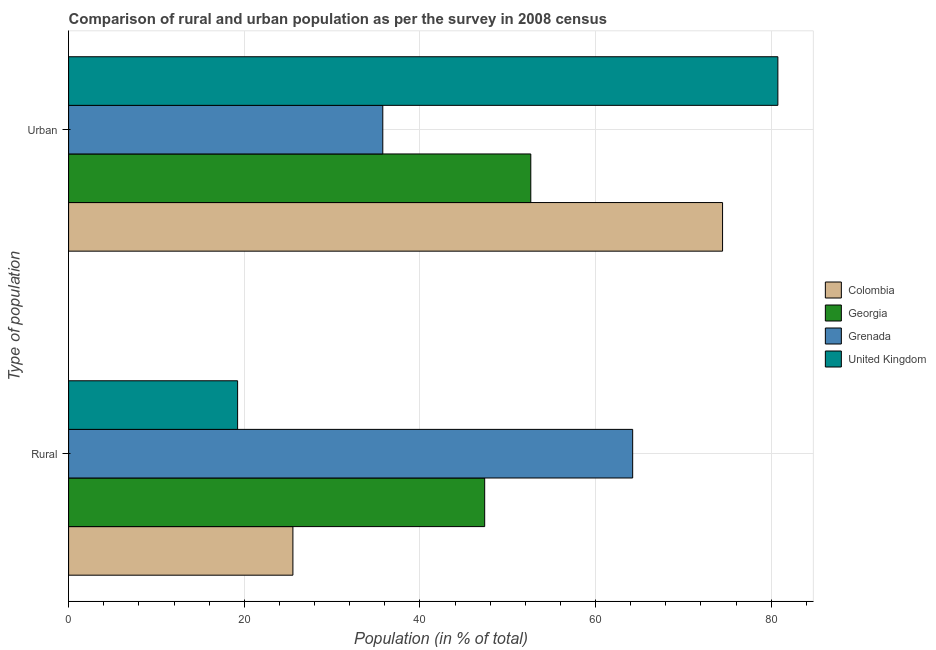How many groups of bars are there?
Offer a terse response. 2. Are the number of bars per tick equal to the number of legend labels?
Provide a succinct answer. Yes. Are the number of bars on each tick of the Y-axis equal?
Provide a succinct answer. Yes. How many bars are there on the 1st tick from the bottom?
Your response must be concise. 4. What is the label of the 1st group of bars from the top?
Make the answer very short. Urban. What is the urban population in Georgia?
Keep it short and to the point. 52.62. Across all countries, what is the maximum rural population?
Make the answer very short. 64.22. Across all countries, what is the minimum rural population?
Offer a terse response. 19.24. In which country was the urban population minimum?
Make the answer very short. Grenada. What is the total rural population in the graph?
Make the answer very short. 156.38. What is the difference between the urban population in Grenada and that in Colombia?
Give a very brief answer. -38.68. What is the difference between the urban population in Grenada and the rural population in United Kingdom?
Offer a terse response. 16.53. What is the average rural population per country?
Provide a succinct answer. 39.1. What is the difference between the rural population and urban population in United Kingdom?
Your answer should be very brief. -61.51. What is the ratio of the urban population in Colombia to that in United Kingdom?
Your answer should be very brief. 0.92. In how many countries, is the urban population greater than the average urban population taken over all countries?
Your answer should be compact. 2. What does the 4th bar from the bottom in Urban represents?
Your answer should be very brief. United Kingdom. Does the graph contain any zero values?
Keep it short and to the point. No. Does the graph contain grids?
Give a very brief answer. Yes. How are the legend labels stacked?
Keep it short and to the point. Vertical. What is the title of the graph?
Your response must be concise. Comparison of rural and urban population as per the survey in 2008 census. What is the label or title of the X-axis?
Make the answer very short. Population (in % of total). What is the label or title of the Y-axis?
Your answer should be very brief. Type of population. What is the Population (in % of total) of Colombia in Rural?
Your response must be concise. 25.54. What is the Population (in % of total) in Georgia in Rural?
Offer a terse response. 47.38. What is the Population (in % of total) in Grenada in Rural?
Your answer should be compact. 64.22. What is the Population (in % of total) of United Kingdom in Rural?
Offer a very short reply. 19.24. What is the Population (in % of total) of Colombia in Urban?
Provide a succinct answer. 74.46. What is the Population (in % of total) of Georgia in Urban?
Offer a terse response. 52.62. What is the Population (in % of total) of Grenada in Urban?
Your answer should be compact. 35.77. What is the Population (in % of total) in United Kingdom in Urban?
Give a very brief answer. 80.76. Across all Type of population, what is the maximum Population (in % of total) of Colombia?
Your answer should be very brief. 74.46. Across all Type of population, what is the maximum Population (in % of total) in Georgia?
Offer a very short reply. 52.62. Across all Type of population, what is the maximum Population (in % of total) in Grenada?
Offer a terse response. 64.22. Across all Type of population, what is the maximum Population (in % of total) of United Kingdom?
Offer a very short reply. 80.76. Across all Type of population, what is the minimum Population (in % of total) of Colombia?
Make the answer very short. 25.54. Across all Type of population, what is the minimum Population (in % of total) of Georgia?
Ensure brevity in your answer.  47.38. Across all Type of population, what is the minimum Population (in % of total) in Grenada?
Offer a very short reply. 35.77. Across all Type of population, what is the minimum Population (in % of total) of United Kingdom?
Provide a short and direct response. 19.24. What is the total Population (in % of total) of Grenada in the graph?
Your answer should be very brief. 100. What is the difference between the Population (in % of total) in Colombia in Rural and that in Urban?
Make the answer very short. -48.92. What is the difference between the Population (in % of total) of Georgia in Rural and that in Urban?
Your answer should be compact. -5.25. What is the difference between the Population (in % of total) of Grenada in Rural and that in Urban?
Give a very brief answer. 28.45. What is the difference between the Population (in % of total) in United Kingdom in Rural and that in Urban?
Provide a succinct answer. -61.51. What is the difference between the Population (in % of total) in Colombia in Rural and the Population (in % of total) in Georgia in Urban?
Ensure brevity in your answer.  -27.09. What is the difference between the Population (in % of total) in Colombia in Rural and the Population (in % of total) in Grenada in Urban?
Ensure brevity in your answer.  -10.23. What is the difference between the Population (in % of total) in Colombia in Rural and the Population (in % of total) in United Kingdom in Urban?
Offer a very short reply. -55.22. What is the difference between the Population (in % of total) in Georgia in Rural and the Population (in % of total) in Grenada in Urban?
Your answer should be compact. 11.6. What is the difference between the Population (in % of total) in Georgia in Rural and the Population (in % of total) in United Kingdom in Urban?
Give a very brief answer. -33.38. What is the difference between the Population (in % of total) in Grenada in Rural and the Population (in % of total) in United Kingdom in Urban?
Ensure brevity in your answer.  -16.53. What is the average Population (in % of total) of Grenada per Type of population?
Keep it short and to the point. 50. What is the average Population (in % of total) of United Kingdom per Type of population?
Your answer should be very brief. 50. What is the difference between the Population (in % of total) in Colombia and Population (in % of total) in Georgia in Rural?
Keep it short and to the point. -21.84. What is the difference between the Population (in % of total) in Colombia and Population (in % of total) in Grenada in Rural?
Ensure brevity in your answer.  -38.69. What is the difference between the Population (in % of total) in Colombia and Population (in % of total) in United Kingdom in Rural?
Your response must be concise. 6.3. What is the difference between the Population (in % of total) in Georgia and Population (in % of total) in Grenada in Rural?
Offer a terse response. -16.85. What is the difference between the Population (in % of total) in Georgia and Population (in % of total) in United Kingdom in Rural?
Provide a succinct answer. 28.13. What is the difference between the Population (in % of total) of Grenada and Population (in % of total) of United Kingdom in Rural?
Give a very brief answer. 44.98. What is the difference between the Population (in % of total) in Colombia and Population (in % of total) in Georgia in Urban?
Give a very brief answer. 21.84. What is the difference between the Population (in % of total) in Colombia and Population (in % of total) in Grenada in Urban?
Ensure brevity in your answer.  38.69. What is the difference between the Population (in % of total) of Colombia and Population (in % of total) of United Kingdom in Urban?
Provide a succinct answer. -6.3. What is the difference between the Population (in % of total) of Georgia and Population (in % of total) of Grenada in Urban?
Provide a succinct answer. 16.85. What is the difference between the Population (in % of total) of Georgia and Population (in % of total) of United Kingdom in Urban?
Provide a succinct answer. -28.13. What is the difference between the Population (in % of total) of Grenada and Population (in % of total) of United Kingdom in Urban?
Offer a terse response. -44.98. What is the ratio of the Population (in % of total) of Colombia in Rural to that in Urban?
Your answer should be compact. 0.34. What is the ratio of the Population (in % of total) in Georgia in Rural to that in Urban?
Provide a succinct answer. 0.9. What is the ratio of the Population (in % of total) in Grenada in Rural to that in Urban?
Offer a terse response. 1.8. What is the ratio of the Population (in % of total) of United Kingdom in Rural to that in Urban?
Your answer should be very brief. 0.24. What is the difference between the highest and the second highest Population (in % of total) in Colombia?
Your response must be concise. 48.92. What is the difference between the highest and the second highest Population (in % of total) of Georgia?
Offer a very short reply. 5.25. What is the difference between the highest and the second highest Population (in % of total) of Grenada?
Make the answer very short. 28.45. What is the difference between the highest and the second highest Population (in % of total) of United Kingdom?
Provide a short and direct response. 61.51. What is the difference between the highest and the lowest Population (in % of total) in Colombia?
Ensure brevity in your answer.  48.92. What is the difference between the highest and the lowest Population (in % of total) of Georgia?
Provide a succinct answer. 5.25. What is the difference between the highest and the lowest Population (in % of total) in Grenada?
Ensure brevity in your answer.  28.45. What is the difference between the highest and the lowest Population (in % of total) in United Kingdom?
Offer a very short reply. 61.51. 